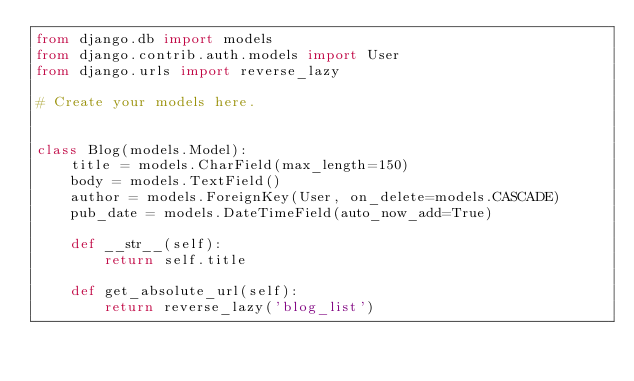Convert code to text. <code><loc_0><loc_0><loc_500><loc_500><_Python_>from django.db import models
from django.contrib.auth.models import User
from django.urls import reverse_lazy

# Create your models here.


class Blog(models.Model):
    title = models.CharField(max_length=150)
    body = models.TextField()
    author = models.ForeignKey(User, on_delete=models.CASCADE)
    pub_date = models.DateTimeField(auto_now_add=True)

    def __str__(self):
        return self.title

    def get_absolute_url(self):
        return reverse_lazy('blog_list')
</code> 